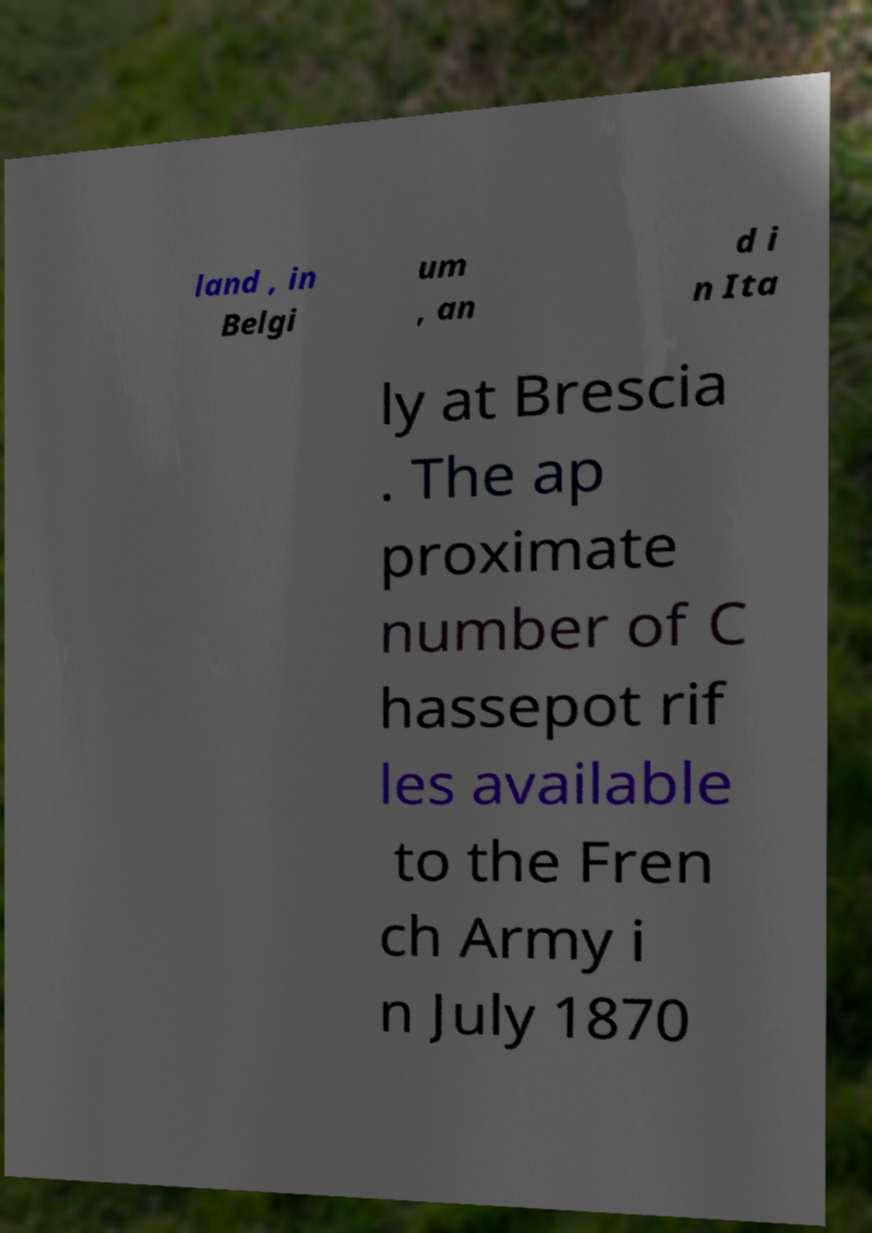For documentation purposes, I need the text within this image transcribed. Could you provide that? land , in Belgi um , an d i n Ita ly at Brescia . The ap proximate number of C hassepot rif les available to the Fren ch Army i n July 1870 